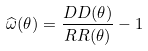Convert formula to latex. <formula><loc_0><loc_0><loc_500><loc_500>\widehat { \omega } ( \theta ) = \frac { D D ( \theta ) } { R R ( \theta ) } - 1</formula> 